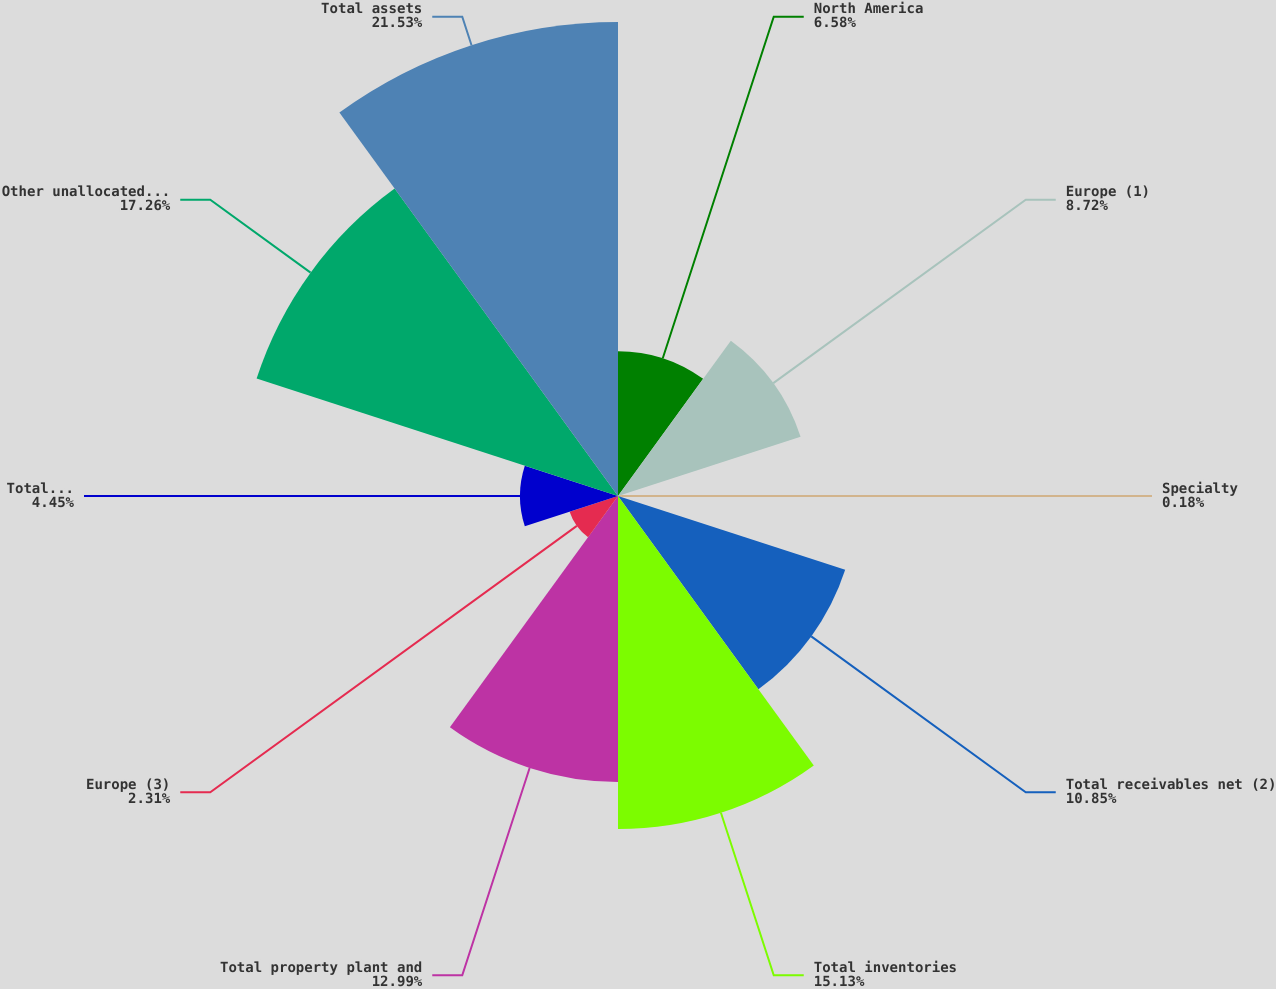<chart> <loc_0><loc_0><loc_500><loc_500><pie_chart><fcel>North America<fcel>Europe (1)<fcel>Specialty<fcel>Total receivables net (2)<fcel>Total inventories<fcel>Total property plant and<fcel>Europe (3)<fcel>Total equity method<fcel>Other unallocated assets<fcel>Total assets<nl><fcel>6.58%<fcel>8.72%<fcel>0.18%<fcel>10.85%<fcel>15.13%<fcel>12.99%<fcel>2.31%<fcel>4.45%<fcel>17.26%<fcel>21.53%<nl></chart> 